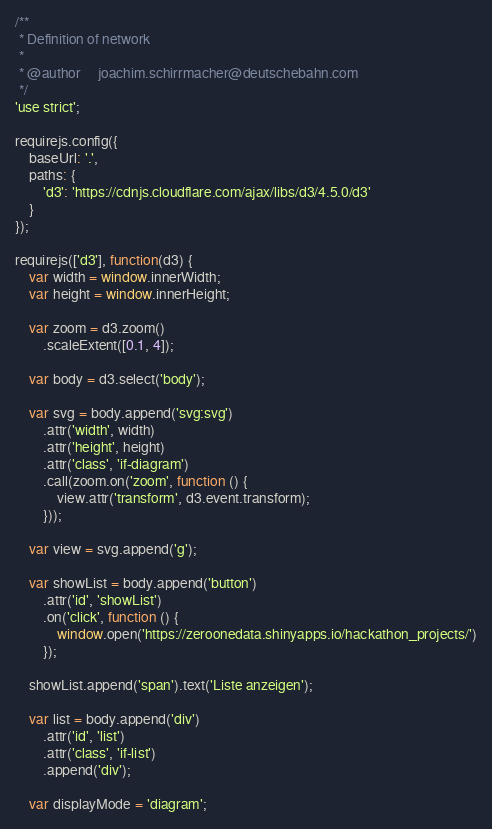Convert code to text. <code><loc_0><loc_0><loc_500><loc_500><_JavaScript_>/**
 * Definition of network
 *
 * @author     joachim.schirrmacher@deutschebahn.com
 */
'use strict';

requirejs.config({
    baseUrl: '.',
    paths: {
        'd3': 'https://cdnjs.cloudflare.com/ajax/libs/d3/4.5.0/d3'
    }
});

requirejs(['d3'], function(d3) {
    var width = window.innerWidth;
    var height = window.innerHeight;

    var zoom = d3.zoom()
        .scaleExtent([0.1, 4]);

    var body = d3.select('body');

    var svg = body.append('svg:svg')
        .attr('width', width)
        .attr('height', height)
        .attr('class', 'if-diagram')
        .call(zoom.on('zoom', function () {
            view.attr('transform', d3.event.transform);
        }));

    var view = svg.append('g');

    var showList = body.append('button')
        .attr('id', 'showList')
        .on('click', function () {
            window.open('https://zeroonedata.shinyapps.io/hackathon_projects/')
        });

    showList.append('span').text('Liste anzeigen');

    var list = body.append('div')
        .attr('id', 'list')
        .attr('class', 'if-list')
        .append('div');

    var displayMode = 'diagram';</code> 